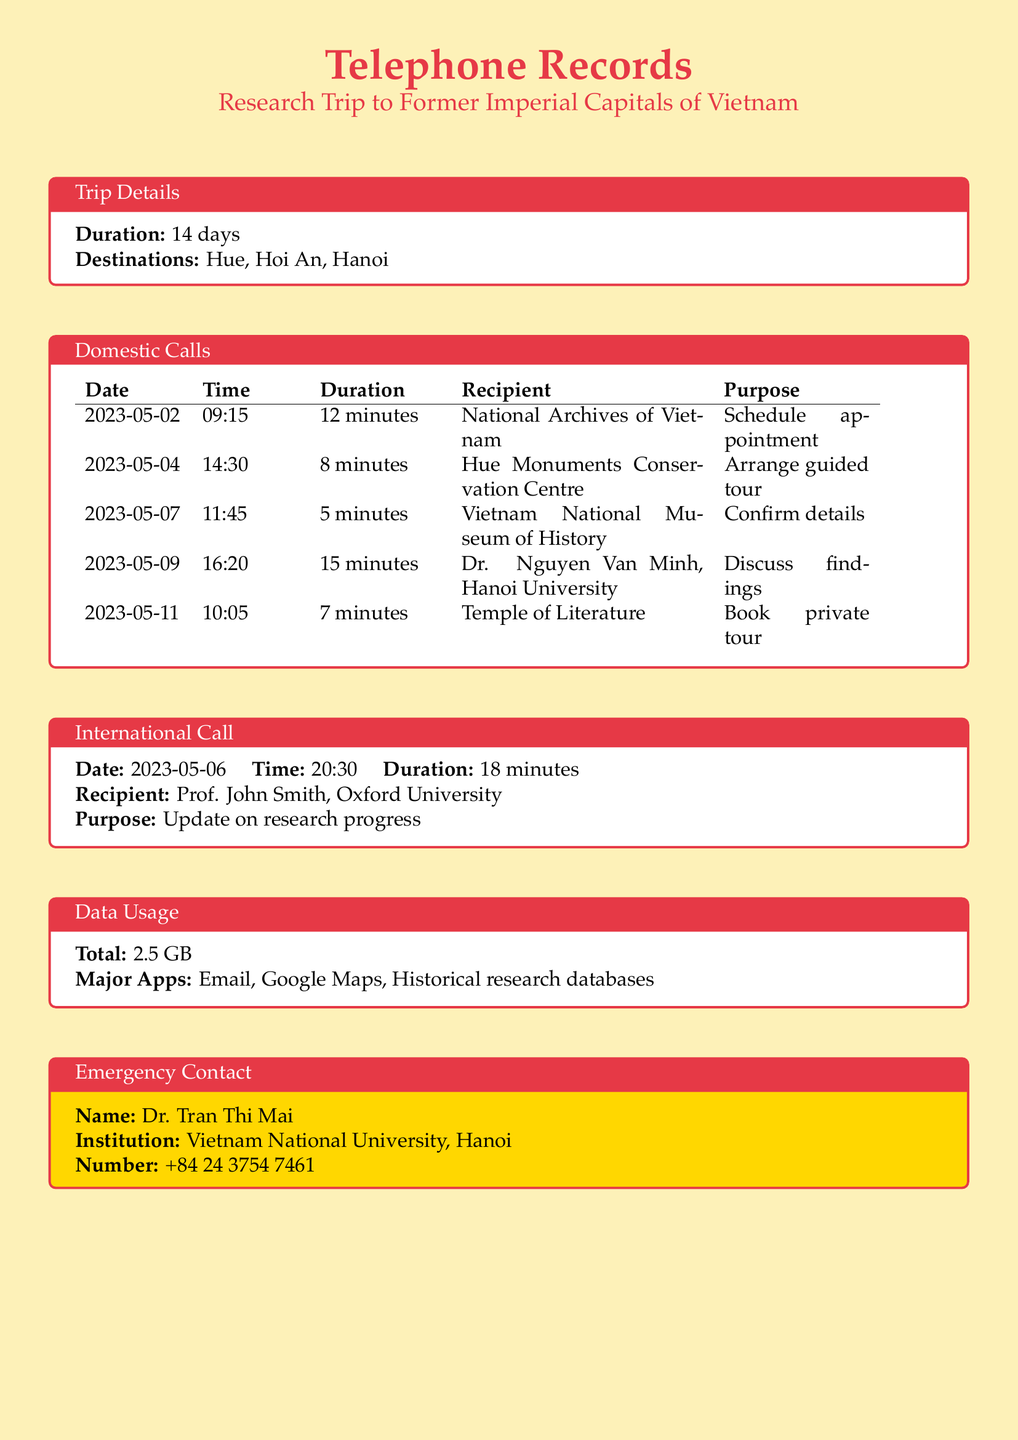What is the total duration of the trip? The total duration is mentioned in the trip details as 14 days.
Answer: 14 days Which cities were included in the research trip? The destinations listed in the trip details are Hue, Hoi An, and Hanoi.
Answer: Hue, Hoi An, Hanoi What was the purpose of the call to the National Archives of Vietnam? The document states that the call was to schedule an appointment.
Answer: Schedule appointment Who was the recipient of the international call? The recipient of the international call is specified in the document as Prof. John Smith.
Answer: Prof. John Smith How many minutes was the call to Dr. Nguyen Van Minh? The duration of the call is specified in the table under Domestic Calls as 15 minutes.
Answer: 15 minutes What apps contributed to the data usage? The major apps used during the trip are listed as Email, Google Maps, and Historical research databases.
Answer: Email, Google Maps, Historical research databases What was the duration of the call made on May 11? The document indicates that the call on May 11 lasted for 7 minutes.
Answer: 7 minutes What is the contact number for the emergency contact? The contact number for Dr. Tran Thi Mai is listed as +84 24 3754 7461.
Answer: +84 24 3754 7461 What was discussed with Dr. Nguyen Van Minh? The purpose of the call to Dr. Nguyen Van Minh was to discuss findings.
Answer: Discuss findings 